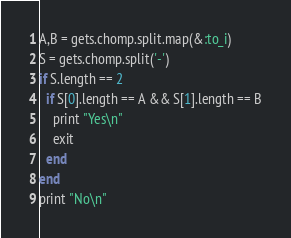Convert code to text. <code><loc_0><loc_0><loc_500><loc_500><_Ruby_>A,B = gets.chomp.split.map(&:to_i)
S = gets.chomp.split('-')
if S.length == 2
  if S[0].length == A && S[1].length == B
    print "Yes\n"
    exit
  end
end
print "No\n"</code> 